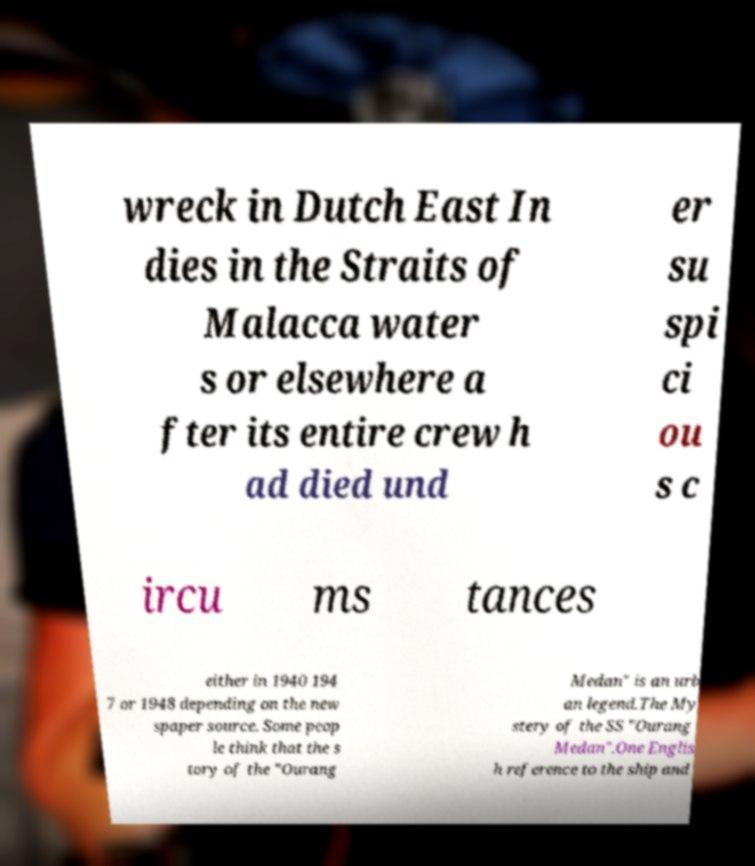Could you extract and type out the text from this image? wreck in Dutch East In dies in the Straits of Malacca water s or elsewhere a fter its entire crew h ad died und er su spi ci ou s c ircu ms tances either in 1940 194 7 or 1948 depending on the new spaper source. Some peop le think that the s tory of the "Ourang Medan" is an urb an legend.The My stery of the SS "Ourang Medan".One Englis h reference to the ship and 